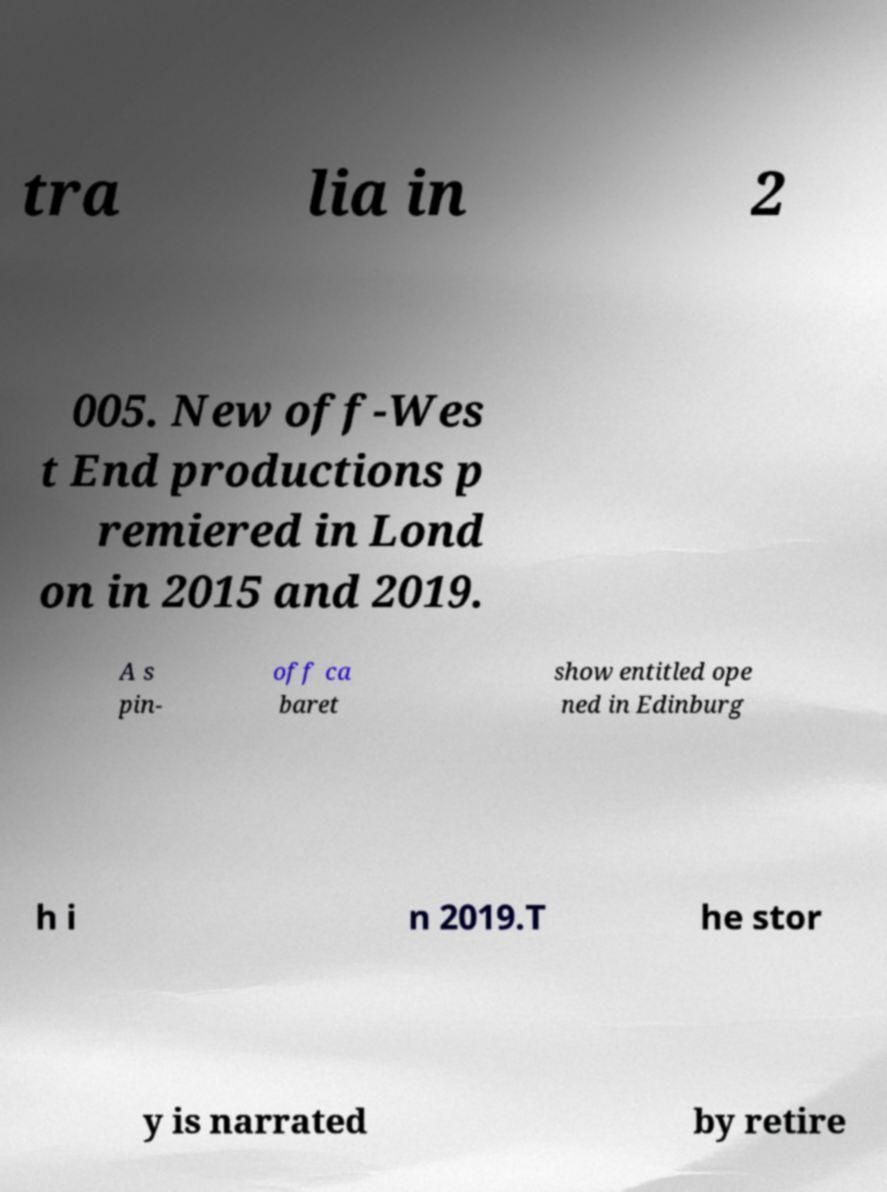Please read and relay the text visible in this image. What does it say? tra lia in 2 005. New off-Wes t End productions p remiered in Lond on in 2015 and 2019. A s pin- off ca baret show entitled ope ned in Edinburg h i n 2019.T he stor y is narrated by retire 